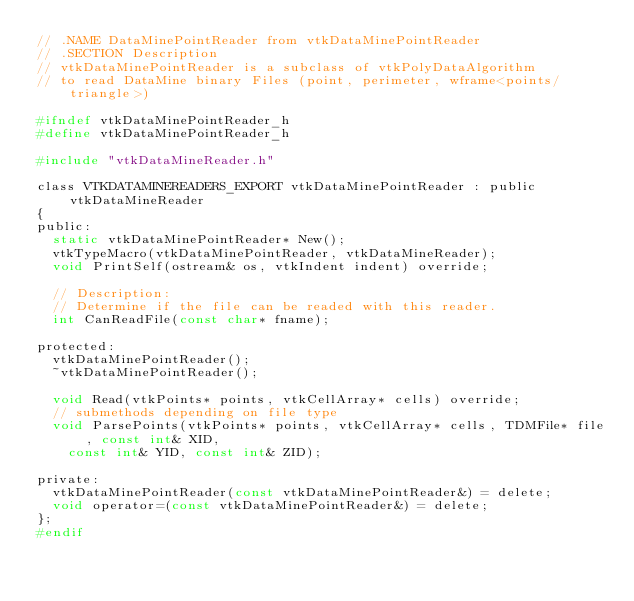<code> <loc_0><loc_0><loc_500><loc_500><_C_>// .NAME DataMinePointReader from vtkDataMinePointReader
// .SECTION Description
// vtkDataMinePointReader is a subclass of vtkPolyDataAlgorithm
// to read DataMine binary Files (point, perimeter, wframe<points/triangle>)

#ifndef vtkDataMinePointReader_h
#define vtkDataMinePointReader_h

#include "vtkDataMineReader.h"

class VTKDATAMINEREADERS_EXPORT vtkDataMinePointReader : public vtkDataMineReader
{
public:
  static vtkDataMinePointReader* New();
  vtkTypeMacro(vtkDataMinePointReader, vtkDataMineReader);
  void PrintSelf(ostream& os, vtkIndent indent) override;

  // Description:
  // Determine if the file can be readed with this reader.
  int CanReadFile(const char* fname);

protected:
  vtkDataMinePointReader();
  ~vtkDataMinePointReader();

  void Read(vtkPoints* points, vtkCellArray* cells) override;
  // submethods depending on file type
  void ParsePoints(vtkPoints* points, vtkCellArray* cells, TDMFile* file, const int& XID,
    const int& YID, const int& ZID);

private:
  vtkDataMinePointReader(const vtkDataMinePointReader&) = delete;
  void operator=(const vtkDataMinePointReader&) = delete;
};
#endif
</code> 